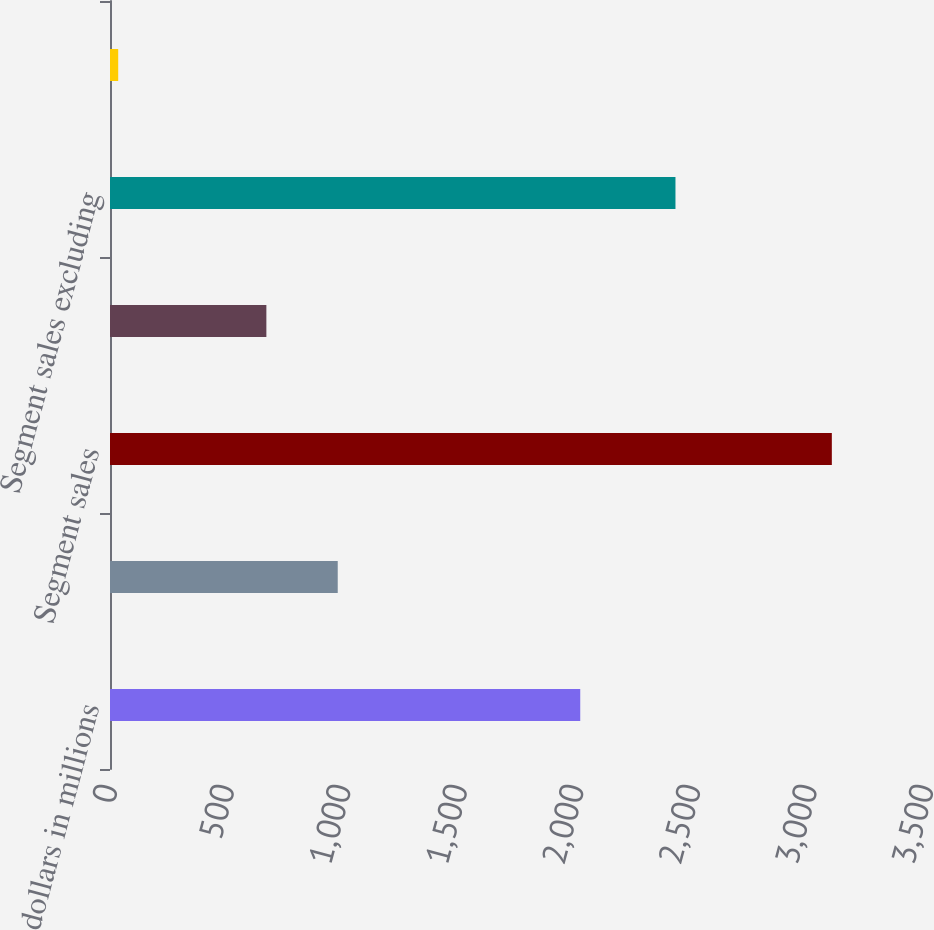Convert chart. <chart><loc_0><loc_0><loc_500><loc_500><bar_chart><fcel>dollars in millions<fcel>Gross profit<fcel>Segment sales<fcel>Freight & delivery revenues ^1<fcel>Segment sales excluding<fcel>excluding freight & delivery<nl><fcel>2017<fcel>976.79<fcel>3096.1<fcel>670.7<fcel>2425.4<fcel>35.2<nl></chart> 